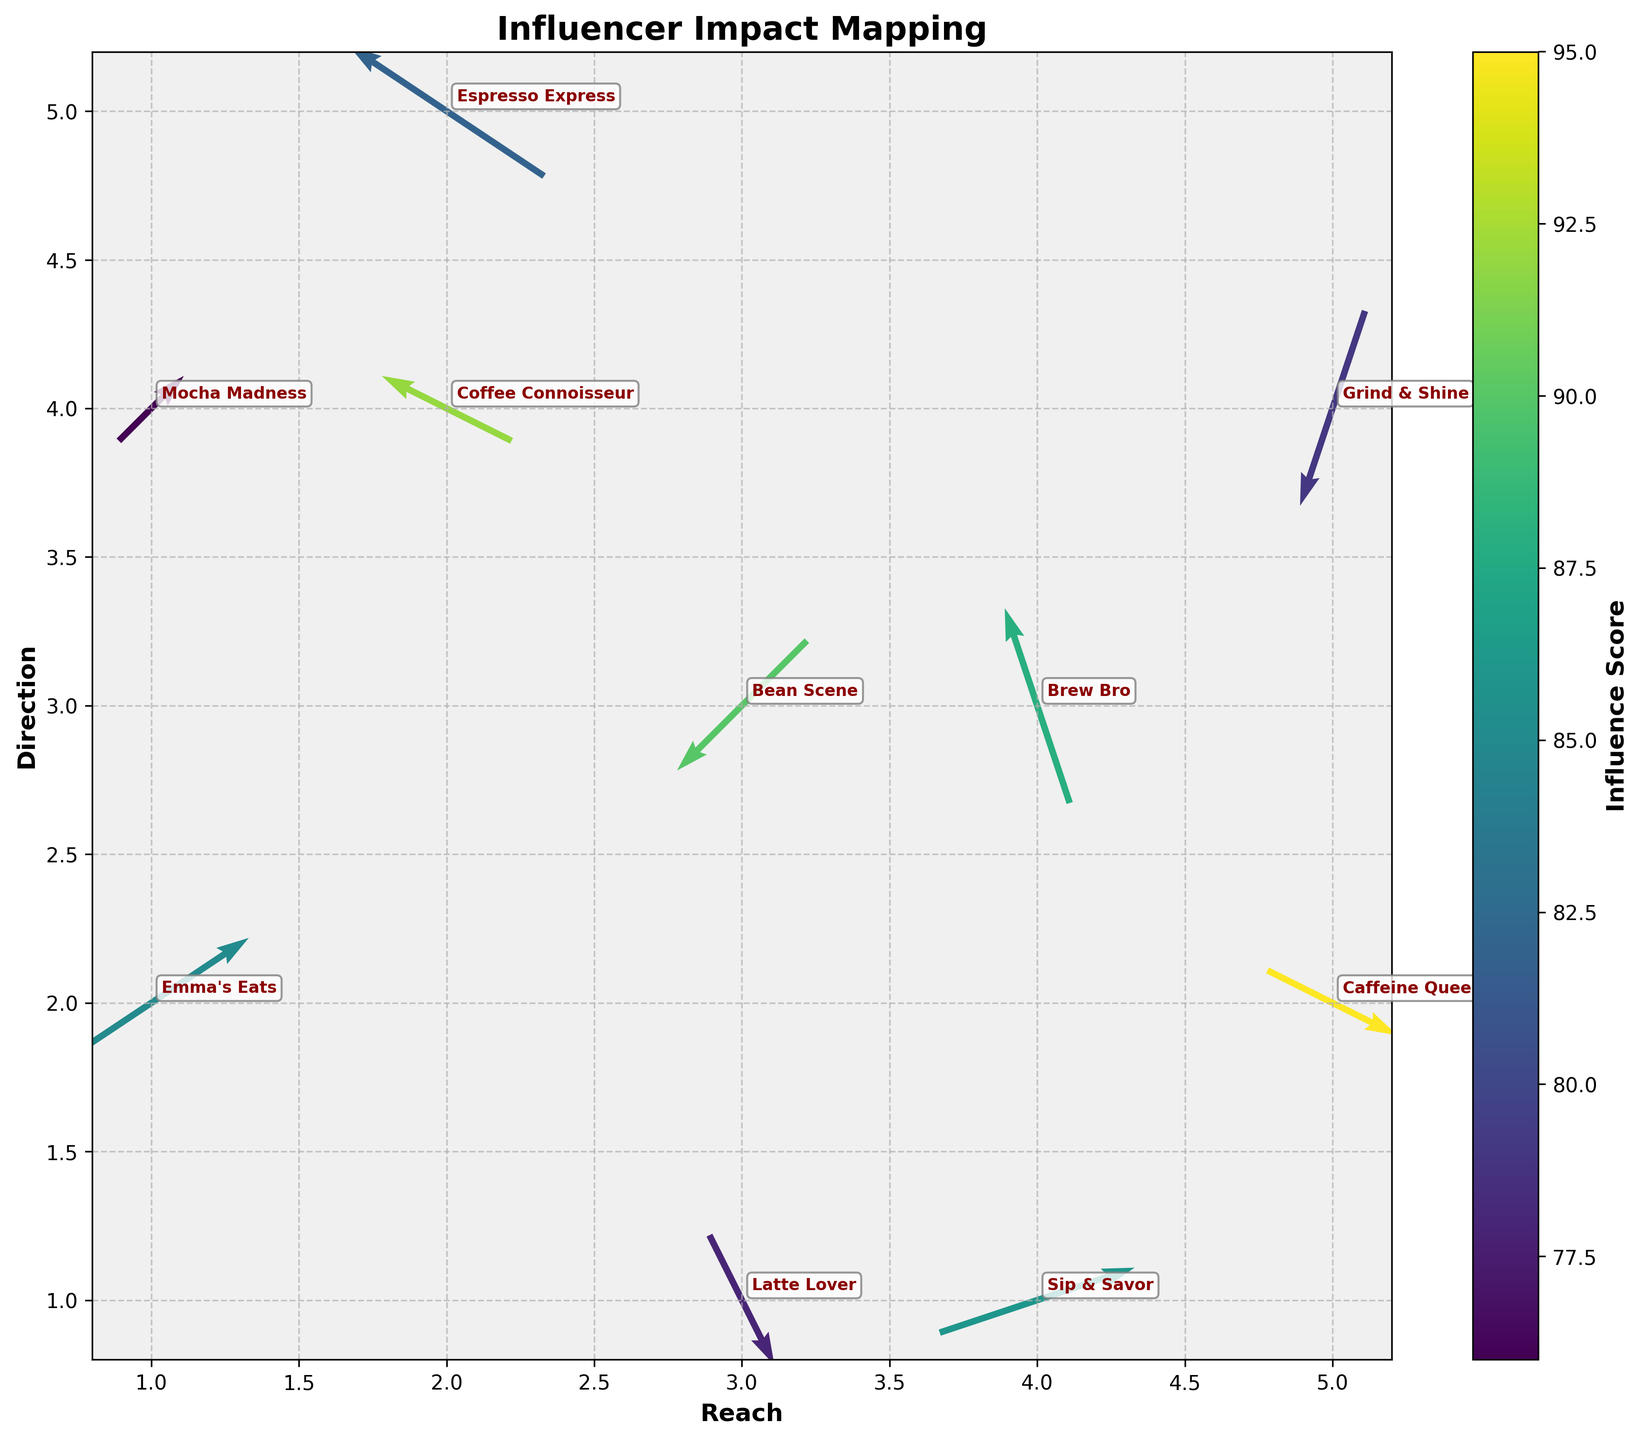What is the title of the figure? The title of the figure is found at the top of the plot. It usually describes the purpose or content of the figure.
Answer: Influencer Impact Mapping How many influencers are shown in the figure? The figure displays each influencer as an annotated text label. Count these labels to find the number of influencers.
Answer: 10 Which influencer has the highest influence score? Look at the color bar and identify the arrow with the color indicating the highest score according to the color map. Read the label next to it.
Answer: Caffeine Queen What are the axis labels? The labels for the x-axis and y-axis are found at the bottom and left of the plot respectively, indicating what each axis represents.
Answer: Reach (x-axis) and Direction (y-axis) What is the direction and reach of 'Bean Scene'? Locate 'Bean Scene' in the plot based on the annotation. Then, observe the direction and reach of the arrow pointing from that point.
Answer: Reach: 3, Direction: 3 Which influencer has the longest arrow, indicating they cover the most ground? Identify the arrow with the largest vector magnitude (combination of u and v components). The annotation next to this arrow gives the influencer name.
Answer: Espresso Express Between 'Emma's Eats' and 'Latte Lover', who has the lower influence score? Locate the arrows for both influencers and compare their colors based on the color bar to determine the influence score.
Answer: Latte Lover What is the direction of movement for 'Grind & Shine'? Locate 'Grind & Shine' and examine the direction of its arrow (vector components u and v). The arrow points in a specific direction in the x,y coordinate system.
Answer: Reach: 5, Direction: 4 How does the reach and direction of 'Sip & Savor' compare to 'Mocha Madness'? Compare the starting points and directions of the arrows for 'Sip & Savor' and 'Mocha Madness', located by their annotations. Provide the differences in their x, y positions and vector directions.
Answer: Sip & Savor: Reach: +3, Direction: +1; Mocha Madness: Reach: +1, Direction: +1 List the influencers who have a positive x-component (reach) in their arrows. Identify arrows that point to the right (positive x-direction), and note the corresponding influencers.
Answer: Emma's Eats, Latte Lover, Caffeine Queen, Sip & Savor 